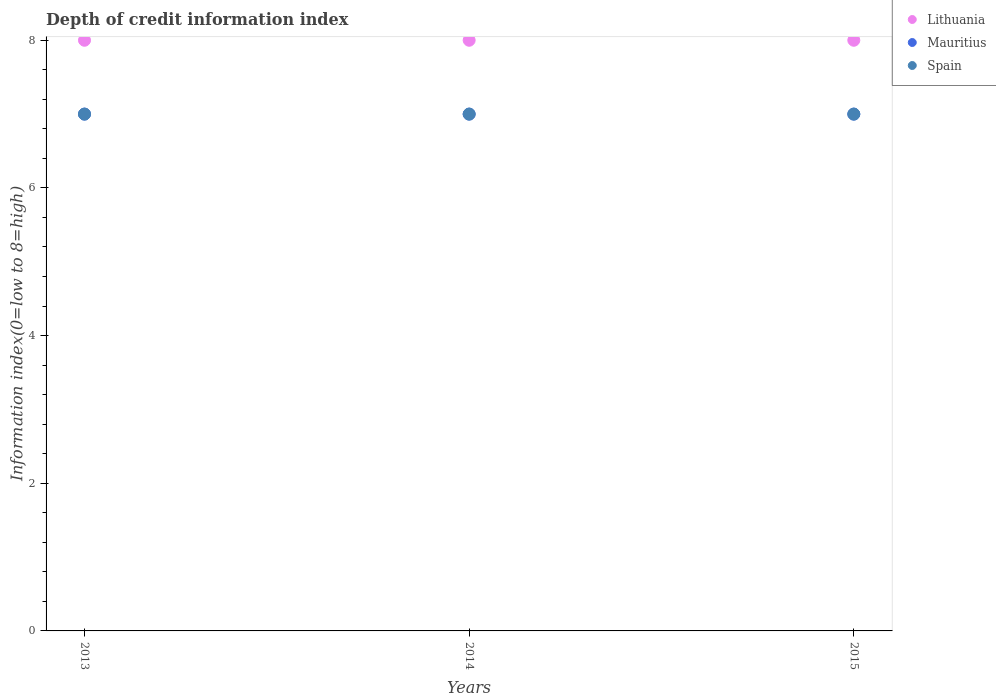How many different coloured dotlines are there?
Provide a succinct answer. 3. Is the number of dotlines equal to the number of legend labels?
Make the answer very short. Yes. What is the information index in Spain in 2015?
Provide a succinct answer. 7. Across all years, what is the maximum information index in Spain?
Give a very brief answer. 7. Across all years, what is the minimum information index in Mauritius?
Give a very brief answer. 7. In which year was the information index in Spain maximum?
Ensure brevity in your answer.  2013. In which year was the information index in Mauritius minimum?
Your response must be concise. 2013. What is the total information index in Lithuania in the graph?
Offer a terse response. 24. What is the difference between the information index in Lithuania in 2013 and that in 2015?
Your answer should be very brief. 0. What is the difference between the information index in Spain in 2015 and the information index in Lithuania in 2014?
Offer a very short reply. -1. What is the average information index in Spain per year?
Your response must be concise. 7. In the year 2014, what is the difference between the information index in Mauritius and information index in Spain?
Ensure brevity in your answer.  0. Is the information index in Mauritius in 2013 less than that in 2014?
Your answer should be very brief. No. Is the difference between the information index in Mauritius in 2013 and 2015 greater than the difference between the information index in Spain in 2013 and 2015?
Provide a succinct answer. No. What is the difference between the highest and the second highest information index in Lithuania?
Offer a very short reply. 0. In how many years, is the information index in Lithuania greater than the average information index in Lithuania taken over all years?
Your response must be concise. 0. Does the information index in Mauritius monotonically increase over the years?
Give a very brief answer. No. Are the values on the major ticks of Y-axis written in scientific E-notation?
Offer a very short reply. No. Does the graph contain grids?
Offer a very short reply. No. How are the legend labels stacked?
Give a very brief answer. Vertical. What is the title of the graph?
Offer a terse response. Depth of credit information index. Does "Sub-Saharan Africa (all income levels)" appear as one of the legend labels in the graph?
Provide a succinct answer. No. What is the label or title of the X-axis?
Keep it short and to the point. Years. What is the label or title of the Y-axis?
Your answer should be compact. Information index(0=low to 8=high). What is the Information index(0=low to 8=high) in Lithuania in 2014?
Provide a short and direct response. 8. What is the Information index(0=low to 8=high) in Mauritius in 2014?
Keep it short and to the point. 7. What is the Information index(0=low to 8=high) of Spain in 2015?
Your answer should be compact. 7. Across all years, what is the minimum Information index(0=low to 8=high) in Mauritius?
Make the answer very short. 7. What is the total Information index(0=low to 8=high) of Mauritius in the graph?
Provide a short and direct response. 21. What is the total Information index(0=low to 8=high) of Spain in the graph?
Provide a succinct answer. 21. What is the difference between the Information index(0=low to 8=high) in Mauritius in 2013 and that in 2014?
Offer a very short reply. 0. What is the difference between the Information index(0=low to 8=high) of Mauritius in 2013 and that in 2015?
Make the answer very short. 0. What is the difference between the Information index(0=low to 8=high) in Spain in 2013 and that in 2015?
Give a very brief answer. 0. What is the difference between the Information index(0=low to 8=high) of Mauritius in 2013 and the Information index(0=low to 8=high) of Spain in 2014?
Provide a short and direct response. 0. What is the difference between the Information index(0=low to 8=high) in Lithuania in 2013 and the Information index(0=low to 8=high) in Mauritius in 2015?
Your response must be concise. 1. What is the difference between the Information index(0=low to 8=high) of Lithuania in 2013 and the Information index(0=low to 8=high) of Spain in 2015?
Keep it short and to the point. 1. What is the difference between the Information index(0=low to 8=high) in Mauritius in 2013 and the Information index(0=low to 8=high) in Spain in 2015?
Ensure brevity in your answer.  0. What is the difference between the Information index(0=low to 8=high) of Lithuania in 2014 and the Information index(0=low to 8=high) of Mauritius in 2015?
Ensure brevity in your answer.  1. What is the difference between the Information index(0=low to 8=high) of Lithuania in 2014 and the Information index(0=low to 8=high) of Spain in 2015?
Your response must be concise. 1. What is the difference between the Information index(0=low to 8=high) in Mauritius in 2014 and the Information index(0=low to 8=high) in Spain in 2015?
Offer a very short reply. 0. What is the average Information index(0=low to 8=high) of Mauritius per year?
Provide a short and direct response. 7. In the year 2013, what is the difference between the Information index(0=low to 8=high) in Lithuania and Information index(0=low to 8=high) in Mauritius?
Your answer should be very brief. 1. In the year 2013, what is the difference between the Information index(0=low to 8=high) in Lithuania and Information index(0=low to 8=high) in Spain?
Your response must be concise. 1. In the year 2013, what is the difference between the Information index(0=low to 8=high) in Mauritius and Information index(0=low to 8=high) in Spain?
Your answer should be very brief. 0. In the year 2014, what is the difference between the Information index(0=low to 8=high) of Lithuania and Information index(0=low to 8=high) of Spain?
Ensure brevity in your answer.  1. In the year 2015, what is the difference between the Information index(0=low to 8=high) in Lithuania and Information index(0=low to 8=high) in Mauritius?
Keep it short and to the point. 1. What is the ratio of the Information index(0=low to 8=high) of Lithuania in 2013 to that in 2014?
Provide a succinct answer. 1. What is the ratio of the Information index(0=low to 8=high) in Mauritius in 2013 to that in 2014?
Make the answer very short. 1. What is the ratio of the Information index(0=low to 8=high) of Spain in 2013 to that in 2014?
Your response must be concise. 1. What is the ratio of the Information index(0=low to 8=high) of Mauritius in 2013 to that in 2015?
Make the answer very short. 1. What is the ratio of the Information index(0=low to 8=high) in Spain in 2013 to that in 2015?
Provide a succinct answer. 1. What is the difference between the highest and the second highest Information index(0=low to 8=high) of Lithuania?
Give a very brief answer. 0. What is the difference between the highest and the second highest Information index(0=low to 8=high) of Mauritius?
Make the answer very short. 0. What is the difference between the highest and the second highest Information index(0=low to 8=high) in Spain?
Make the answer very short. 0. What is the difference between the highest and the lowest Information index(0=low to 8=high) of Lithuania?
Offer a terse response. 0. What is the difference between the highest and the lowest Information index(0=low to 8=high) of Mauritius?
Offer a terse response. 0. 